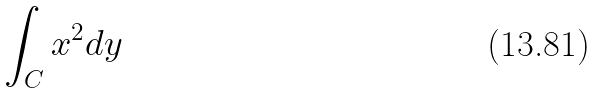<formula> <loc_0><loc_0><loc_500><loc_500>\int _ { C } x ^ { 2 } d y</formula> 